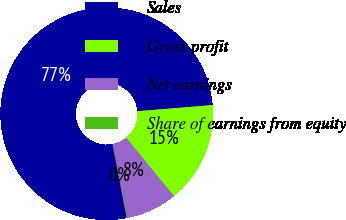Convert chart. <chart><loc_0><loc_0><loc_500><loc_500><pie_chart><fcel>Sales<fcel>Gross profit<fcel>Net earnings<fcel>Share of earnings from equity<nl><fcel>76.71%<fcel>15.42%<fcel>7.76%<fcel>0.1%<nl></chart> 